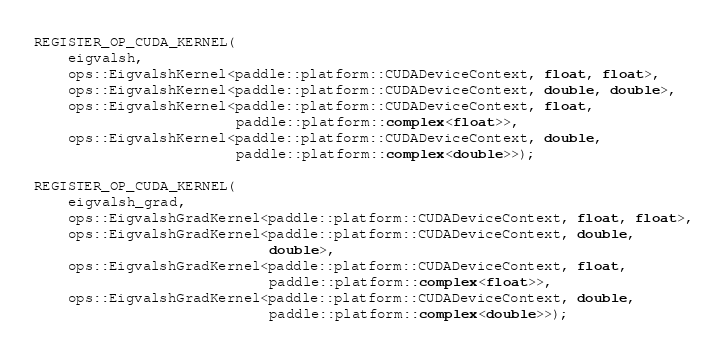<code> <loc_0><loc_0><loc_500><loc_500><_Cuda_>REGISTER_OP_CUDA_KERNEL(
    eigvalsh,
    ops::EigvalshKernel<paddle::platform::CUDADeviceContext, float, float>,
    ops::EigvalshKernel<paddle::platform::CUDADeviceContext, double, double>,
    ops::EigvalshKernel<paddle::platform::CUDADeviceContext, float,
                        paddle::platform::complex<float>>,
    ops::EigvalshKernel<paddle::platform::CUDADeviceContext, double,
                        paddle::platform::complex<double>>);

REGISTER_OP_CUDA_KERNEL(
    eigvalsh_grad,
    ops::EigvalshGradKernel<paddle::platform::CUDADeviceContext, float, float>,
    ops::EigvalshGradKernel<paddle::platform::CUDADeviceContext, double,
                            double>,
    ops::EigvalshGradKernel<paddle::platform::CUDADeviceContext, float,
                            paddle::platform::complex<float>>,
    ops::EigvalshGradKernel<paddle::platform::CUDADeviceContext, double,
                            paddle::platform::complex<double>>);
</code> 